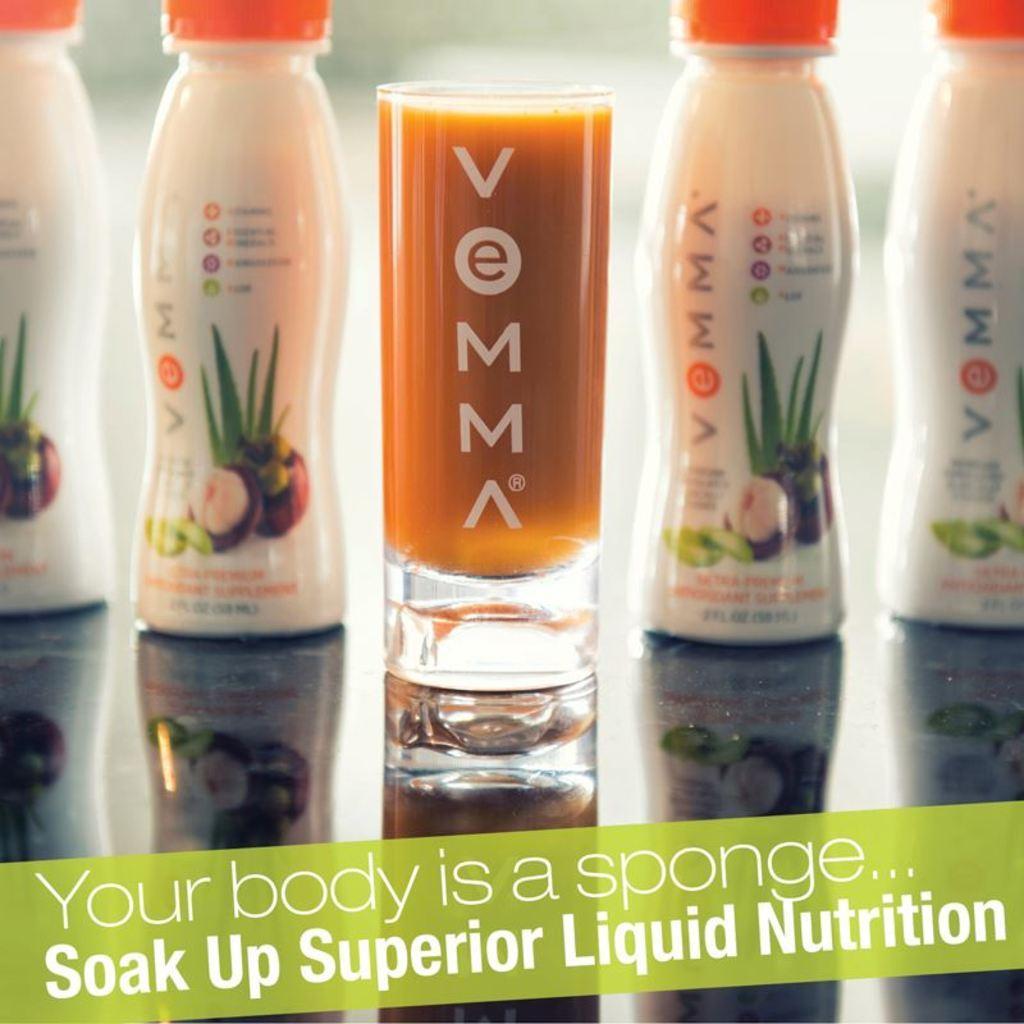How would you summarize this image in a sentence or two? This image consists of 4 Bottles And a glass. Four bottles are in white color ,two are on right side and 2 are on left side. all 4 of them have orange color caps. The glass is in the middle which has orange color drink in it and in the bottom there is written something like your body is a sponge soak up superior liquid nutrition. 